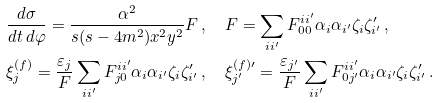Convert formula to latex. <formula><loc_0><loc_0><loc_500><loc_500>& \frac { d \sigma } { d t \, d \varphi } = \frac { \alpha ^ { 2 } } { s ( s - 4 m ^ { 2 } ) x ^ { 2 } y ^ { 2 } } F \, , \quad F = \sum _ { i i ^ { \prime } } F ^ { i i ^ { \prime } } _ { 0 0 } \alpha _ { i } \alpha _ { i ^ { \prime } } \zeta _ { i } \zeta ^ { \prime } _ { i ^ { \prime } } \, , \\ & \xi ^ { ( f ) } _ { j } = \frac { \varepsilon _ { j } } { F } \sum _ { i i ^ { \prime } } F ^ { i i ^ { \prime } } _ { j 0 } \alpha _ { i } \alpha _ { i ^ { \prime } } \zeta _ { i } \zeta ^ { \prime } _ { i ^ { \prime } } \, , \quad \xi ^ { ( f ) \prime } _ { j ^ { \prime } } = \frac { \varepsilon _ { j ^ { \prime } } } { F } \sum _ { i i ^ { \prime } } F ^ { i i ^ { \prime } } _ { 0 j ^ { \prime } } \alpha _ { i } \alpha _ { i ^ { \prime } } \zeta _ { i } \zeta ^ { \prime } _ { i ^ { \prime } } \, .</formula> 